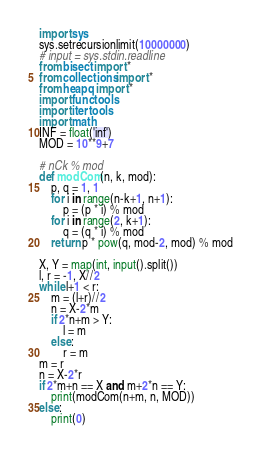<code> <loc_0><loc_0><loc_500><loc_500><_Python_>import sys
sys.setrecursionlimit(10000000)
# input = sys.stdin.readline
from bisect import *
from collections import *
from heapq import *
import functools
import itertools
import math
INF = float('inf')
MOD = 10**9+7

# nCk % mod
def modCom(n, k, mod):
    p, q = 1, 1
    for i in range(n-k+1, n+1):
        p = (p * i) % mod
    for i in range(2, k+1):
        q = (q * i) % mod
    return p * pow(q, mod-2, mod) % mod

X, Y = map(int, input().split())
l, r = -1, X//2
while l+1 < r:
    m = (l+r)//2
    n = X-2*m
    if 2*n+m > Y:
        l = m
    else:
        r = m
m = r
n = X-2*r
if 2*m+n == X and m+2*n == Y:
    print(modCom(n+m, n, MOD))
else:
    print(0)</code> 